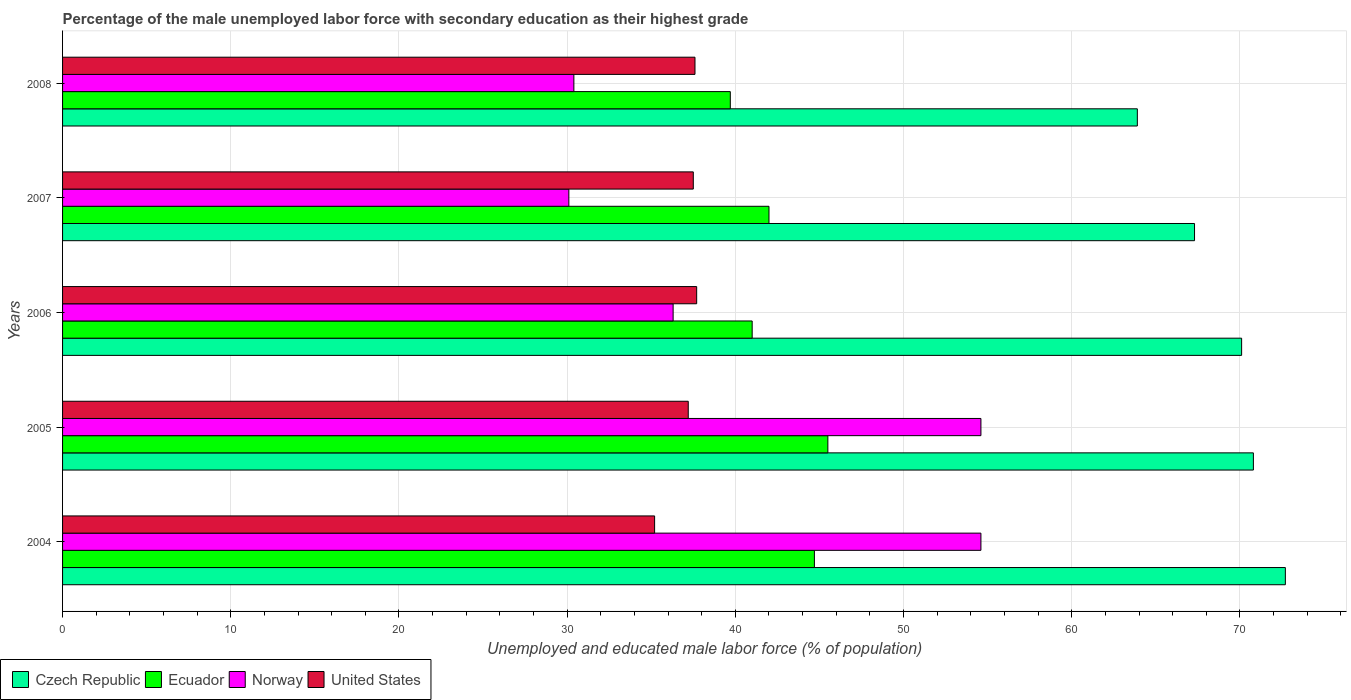How many groups of bars are there?
Give a very brief answer. 5. How many bars are there on the 3rd tick from the top?
Offer a very short reply. 4. How many bars are there on the 4th tick from the bottom?
Offer a very short reply. 4. What is the label of the 1st group of bars from the top?
Keep it short and to the point. 2008. What is the percentage of the unemployed male labor force with secondary education in Czech Republic in 2006?
Your answer should be very brief. 70.1. Across all years, what is the maximum percentage of the unemployed male labor force with secondary education in Ecuador?
Your response must be concise. 45.5. Across all years, what is the minimum percentage of the unemployed male labor force with secondary education in Ecuador?
Your response must be concise. 39.7. In which year was the percentage of the unemployed male labor force with secondary education in Czech Republic maximum?
Offer a very short reply. 2004. What is the total percentage of the unemployed male labor force with secondary education in United States in the graph?
Make the answer very short. 185.2. What is the difference between the percentage of the unemployed male labor force with secondary education in Norway in 2005 and that in 2008?
Offer a very short reply. 24.2. What is the difference between the percentage of the unemployed male labor force with secondary education in Czech Republic in 2004 and the percentage of the unemployed male labor force with secondary education in United States in 2006?
Make the answer very short. 35. What is the average percentage of the unemployed male labor force with secondary education in Norway per year?
Offer a very short reply. 41.2. In the year 2005, what is the difference between the percentage of the unemployed male labor force with secondary education in United States and percentage of the unemployed male labor force with secondary education in Ecuador?
Give a very brief answer. -8.3. In how many years, is the percentage of the unemployed male labor force with secondary education in Ecuador greater than 42 %?
Keep it short and to the point. 2. What is the ratio of the percentage of the unemployed male labor force with secondary education in Czech Republic in 2007 to that in 2008?
Provide a short and direct response. 1.05. Is the difference between the percentage of the unemployed male labor force with secondary education in United States in 2006 and 2008 greater than the difference between the percentage of the unemployed male labor force with secondary education in Ecuador in 2006 and 2008?
Offer a very short reply. No. What is the difference between the highest and the second highest percentage of the unemployed male labor force with secondary education in Norway?
Keep it short and to the point. 0. What is the difference between the highest and the lowest percentage of the unemployed male labor force with secondary education in Ecuador?
Your answer should be compact. 5.8. In how many years, is the percentage of the unemployed male labor force with secondary education in Czech Republic greater than the average percentage of the unemployed male labor force with secondary education in Czech Republic taken over all years?
Ensure brevity in your answer.  3. Is the sum of the percentage of the unemployed male labor force with secondary education in United States in 2007 and 2008 greater than the maximum percentage of the unemployed male labor force with secondary education in Norway across all years?
Your response must be concise. Yes. What does the 2nd bar from the top in 2006 represents?
Offer a terse response. Norway. What does the 2nd bar from the bottom in 2004 represents?
Give a very brief answer. Ecuador. Is it the case that in every year, the sum of the percentage of the unemployed male labor force with secondary education in Norway and percentage of the unemployed male labor force with secondary education in Czech Republic is greater than the percentage of the unemployed male labor force with secondary education in United States?
Keep it short and to the point. Yes. How many bars are there?
Provide a succinct answer. 20. Are all the bars in the graph horizontal?
Your answer should be very brief. Yes. Are the values on the major ticks of X-axis written in scientific E-notation?
Keep it short and to the point. No. Does the graph contain any zero values?
Your response must be concise. No. Does the graph contain grids?
Your answer should be compact. Yes. Where does the legend appear in the graph?
Provide a short and direct response. Bottom left. How many legend labels are there?
Ensure brevity in your answer.  4. How are the legend labels stacked?
Make the answer very short. Horizontal. What is the title of the graph?
Make the answer very short. Percentage of the male unemployed labor force with secondary education as their highest grade. Does "United Arab Emirates" appear as one of the legend labels in the graph?
Offer a terse response. No. What is the label or title of the X-axis?
Give a very brief answer. Unemployed and educated male labor force (% of population). What is the label or title of the Y-axis?
Provide a short and direct response. Years. What is the Unemployed and educated male labor force (% of population) in Czech Republic in 2004?
Provide a succinct answer. 72.7. What is the Unemployed and educated male labor force (% of population) of Ecuador in 2004?
Provide a short and direct response. 44.7. What is the Unemployed and educated male labor force (% of population) in Norway in 2004?
Keep it short and to the point. 54.6. What is the Unemployed and educated male labor force (% of population) in United States in 2004?
Keep it short and to the point. 35.2. What is the Unemployed and educated male labor force (% of population) of Czech Republic in 2005?
Keep it short and to the point. 70.8. What is the Unemployed and educated male labor force (% of population) of Ecuador in 2005?
Give a very brief answer. 45.5. What is the Unemployed and educated male labor force (% of population) of Norway in 2005?
Offer a very short reply. 54.6. What is the Unemployed and educated male labor force (% of population) of United States in 2005?
Keep it short and to the point. 37.2. What is the Unemployed and educated male labor force (% of population) in Czech Republic in 2006?
Make the answer very short. 70.1. What is the Unemployed and educated male labor force (% of population) of Norway in 2006?
Your response must be concise. 36.3. What is the Unemployed and educated male labor force (% of population) of United States in 2006?
Provide a succinct answer. 37.7. What is the Unemployed and educated male labor force (% of population) of Czech Republic in 2007?
Your answer should be compact. 67.3. What is the Unemployed and educated male labor force (% of population) in Norway in 2007?
Your answer should be compact. 30.1. What is the Unemployed and educated male labor force (% of population) in United States in 2007?
Keep it short and to the point. 37.5. What is the Unemployed and educated male labor force (% of population) of Czech Republic in 2008?
Your answer should be very brief. 63.9. What is the Unemployed and educated male labor force (% of population) in Ecuador in 2008?
Make the answer very short. 39.7. What is the Unemployed and educated male labor force (% of population) in Norway in 2008?
Provide a short and direct response. 30.4. What is the Unemployed and educated male labor force (% of population) in United States in 2008?
Provide a short and direct response. 37.6. Across all years, what is the maximum Unemployed and educated male labor force (% of population) in Czech Republic?
Provide a short and direct response. 72.7. Across all years, what is the maximum Unemployed and educated male labor force (% of population) of Ecuador?
Make the answer very short. 45.5. Across all years, what is the maximum Unemployed and educated male labor force (% of population) of Norway?
Make the answer very short. 54.6. Across all years, what is the maximum Unemployed and educated male labor force (% of population) in United States?
Offer a very short reply. 37.7. Across all years, what is the minimum Unemployed and educated male labor force (% of population) in Czech Republic?
Provide a succinct answer. 63.9. Across all years, what is the minimum Unemployed and educated male labor force (% of population) in Ecuador?
Offer a terse response. 39.7. Across all years, what is the minimum Unemployed and educated male labor force (% of population) of Norway?
Your response must be concise. 30.1. Across all years, what is the minimum Unemployed and educated male labor force (% of population) in United States?
Your answer should be compact. 35.2. What is the total Unemployed and educated male labor force (% of population) of Czech Republic in the graph?
Offer a very short reply. 344.8. What is the total Unemployed and educated male labor force (% of population) of Ecuador in the graph?
Your response must be concise. 212.9. What is the total Unemployed and educated male labor force (% of population) in Norway in the graph?
Give a very brief answer. 206. What is the total Unemployed and educated male labor force (% of population) of United States in the graph?
Give a very brief answer. 185.2. What is the difference between the Unemployed and educated male labor force (% of population) in Czech Republic in 2004 and that in 2005?
Your response must be concise. 1.9. What is the difference between the Unemployed and educated male labor force (% of population) in Ecuador in 2004 and that in 2005?
Offer a terse response. -0.8. What is the difference between the Unemployed and educated male labor force (% of population) in United States in 2004 and that in 2005?
Your answer should be compact. -2. What is the difference between the Unemployed and educated male labor force (% of population) of Czech Republic in 2004 and that in 2006?
Offer a terse response. 2.6. What is the difference between the Unemployed and educated male labor force (% of population) of Ecuador in 2004 and that in 2006?
Provide a succinct answer. 3.7. What is the difference between the Unemployed and educated male labor force (% of population) in Norway in 2004 and that in 2006?
Make the answer very short. 18.3. What is the difference between the Unemployed and educated male labor force (% of population) in Czech Republic in 2004 and that in 2007?
Offer a very short reply. 5.4. What is the difference between the Unemployed and educated male labor force (% of population) in Ecuador in 2004 and that in 2007?
Your response must be concise. 2.7. What is the difference between the Unemployed and educated male labor force (% of population) in Ecuador in 2004 and that in 2008?
Your answer should be compact. 5. What is the difference between the Unemployed and educated male labor force (% of population) in Norway in 2004 and that in 2008?
Provide a short and direct response. 24.2. What is the difference between the Unemployed and educated male labor force (% of population) in United States in 2004 and that in 2008?
Ensure brevity in your answer.  -2.4. What is the difference between the Unemployed and educated male labor force (% of population) in Czech Republic in 2005 and that in 2006?
Your answer should be very brief. 0.7. What is the difference between the Unemployed and educated male labor force (% of population) in Ecuador in 2005 and that in 2006?
Offer a terse response. 4.5. What is the difference between the Unemployed and educated male labor force (% of population) in Norway in 2005 and that in 2006?
Provide a succinct answer. 18.3. What is the difference between the Unemployed and educated male labor force (% of population) in Czech Republic in 2005 and that in 2007?
Your response must be concise. 3.5. What is the difference between the Unemployed and educated male labor force (% of population) of Norway in 2005 and that in 2007?
Your answer should be compact. 24.5. What is the difference between the Unemployed and educated male labor force (% of population) in United States in 2005 and that in 2007?
Offer a very short reply. -0.3. What is the difference between the Unemployed and educated male labor force (% of population) in Norway in 2005 and that in 2008?
Provide a short and direct response. 24.2. What is the difference between the Unemployed and educated male labor force (% of population) in United States in 2005 and that in 2008?
Offer a terse response. -0.4. What is the difference between the Unemployed and educated male labor force (% of population) in Ecuador in 2006 and that in 2007?
Offer a terse response. -1. What is the difference between the Unemployed and educated male labor force (% of population) in Ecuador in 2006 and that in 2008?
Your answer should be compact. 1.3. What is the difference between the Unemployed and educated male labor force (% of population) in United States in 2006 and that in 2008?
Keep it short and to the point. 0.1. What is the difference between the Unemployed and educated male labor force (% of population) in Czech Republic in 2007 and that in 2008?
Offer a very short reply. 3.4. What is the difference between the Unemployed and educated male labor force (% of population) in Norway in 2007 and that in 2008?
Provide a short and direct response. -0.3. What is the difference between the Unemployed and educated male labor force (% of population) in United States in 2007 and that in 2008?
Provide a short and direct response. -0.1. What is the difference between the Unemployed and educated male labor force (% of population) of Czech Republic in 2004 and the Unemployed and educated male labor force (% of population) of Ecuador in 2005?
Provide a short and direct response. 27.2. What is the difference between the Unemployed and educated male labor force (% of population) in Czech Republic in 2004 and the Unemployed and educated male labor force (% of population) in Norway in 2005?
Your answer should be very brief. 18.1. What is the difference between the Unemployed and educated male labor force (% of population) of Czech Republic in 2004 and the Unemployed and educated male labor force (% of population) of United States in 2005?
Offer a very short reply. 35.5. What is the difference between the Unemployed and educated male labor force (% of population) of Ecuador in 2004 and the Unemployed and educated male labor force (% of population) of Norway in 2005?
Offer a terse response. -9.9. What is the difference between the Unemployed and educated male labor force (% of population) of Czech Republic in 2004 and the Unemployed and educated male labor force (% of population) of Ecuador in 2006?
Make the answer very short. 31.7. What is the difference between the Unemployed and educated male labor force (% of population) of Czech Republic in 2004 and the Unemployed and educated male labor force (% of population) of Norway in 2006?
Ensure brevity in your answer.  36.4. What is the difference between the Unemployed and educated male labor force (% of population) in Ecuador in 2004 and the Unemployed and educated male labor force (% of population) in Norway in 2006?
Provide a succinct answer. 8.4. What is the difference between the Unemployed and educated male labor force (% of population) of Ecuador in 2004 and the Unemployed and educated male labor force (% of population) of United States in 2006?
Make the answer very short. 7. What is the difference between the Unemployed and educated male labor force (% of population) in Norway in 2004 and the Unemployed and educated male labor force (% of population) in United States in 2006?
Ensure brevity in your answer.  16.9. What is the difference between the Unemployed and educated male labor force (% of population) of Czech Republic in 2004 and the Unemployed and educated male labor force (% of population) of Ecuador in 2007?
Your answer should be very brief. 30.7. What is the difference between the Unemployed and educated male labor force (% of population) in Czech Republic in 2004 and the Unemployed and educated male labor force (% of population) in Norway in 2007?
Your answer should be very brief. 42.6. What is the difference between the Unemployed and educated male labor force (% of population) in Czech Republic in 2004 and the Unemployed and educated male labor force (% of population) in United States in 2007?
Offer a terse response. 35.2. What is the difference between the Unemployed and educated male labor force (% of population) of Czech Republic in 2004 and the Unemployed and educated male labor force (% of population) of Norway in 2008?
Provide a short and direct response. 42.3. What is the difference between the Unemployed and educated male labor force (% of population) of Czech Republic in 2004 and the Unemployed and educated male labor force (% of population) of United States in 2008?
Make the answer very short. 35.1. What is the difference between the Unemployed and educated male labor force (% of population) of Ecuador in 2004 and the Unemployed and educated male labor force (% of population) of Norway in 2008?
Give a very brief answer. 14.3. What is the difference between the Unemployed and educated male labor force (% of population) of Ecuador in 2004 and the Unemployed and educated male labor force (% of population) of United States in 2008?
Offer a very short reply. 7.1. What is the difference between the Unemployed and educated male labor force (% of population) of Norway in 2004 and the Unemployed and educated male labor force (% of population) of United States in 2008?
Make the answer very short. 17. What is the difference between the Unemployed and educated male labor force (% of population) of Czech Republic in 2005 and the Unemployed and educated male labor force (% of population) of Ecuador in 2006?
Offer a terse response. 29.8. What is the difference between the Unemployed and educated male labor force (% of population) of Czech Republic in 2005 and the Unemployed and educated male labor force (% of population) of Norway in 2006?
Keep it short and to the point. 34.5. What is the difference between the Unemployed and educated male labor force (% of population) in Czech Republic in 2005 and the Unemployed and educated male labor force (% of population) in United States in 2006?
Make the answer very short. 33.1. What is the difference between the Unemployed and educated male labor force (% of population) of Ecuador in 2005 and the Unemployed and educated male labor force (% of population) of Norway in 2006?
Give a very brief answer. 9.2. What is the difference between the Unemployed and educated male labor force (% of population) of Ecuador in 2005 and the Unemployed and educated male labor force (% of population) of United States in 2006?
Make the answer very short. 7.8. What is the difference between the Unemployed and educated male labor force (% of population) in Czech Republic in 2005 and the Unemployed and educated male labor force (% of population) in Ecuador in 2007?
Your answer should be very brief. 28.8. What is the difference between the Unemployed and educated male labor force (% of population) of Czech Republic in 2005 and the Unemployed and educated male labor force (% of population) of Norway in 2007?
Offer a terse response. 40.7. What is the difference between the Unemployed and educated male labor force (% of population) of Czech Republic in 2005 and the Unemployed and educated male labor force (% of population) of United States in 2007?
Provide a succinct answer. 33.3. What is the difference between the Unemployed and educated male labor force (% of population) of Czech Republic in 2005 and the Unemployed and educated male labor force (% of population) of Ecuador in 2008?
Offer a very short reply. 31.1. What is the difference between the Unemployed and educated male labor force (% of population) of Czech Republic in 2005 and the Unemployed and educated male labor force (% of population) of Norway in 2008?
Make the answer very short. 40.4. What is the difference between the Unemployed and educated male labor force (% of population) of Czech Republic in 2005 and the Unemployed and educated male labor force (% of population) of United States in 2008?
Ensure brevity in your answer.  33.2. What is the difference between the Unemployed and educated male labor force (% of population) of Ecuador in 2005 and the Unemployed and educated male labor force (% of population) of Norway in 2008?
Your response must be concise. 15.1. What is the difference between the Unemployed and educated male labor force (% of population) in Czech Republic in 2006 and the Unemployed and educated male labor force (% of population) in Ecuador in 2007?
Your answer should be very brief. 28.1. What is the difference between the Unemployed and educated male labor force (% of population) of Czech Republic in 2006 and the Unemployed and educated male labor force (% of population) of Norway in 2007?
Your response must be concise. 40. What is the difference between the Unemployed and educated male labor force (% of population) of Czech Republic in 2006 and the Unemployed and educated male labor force (% of population) of United States in 2007?
Your response must be concise. 32.6. What is the difference between the Unemployed and educated male labor force (% of population) in Norway in 2006 and the Unemployed and educated male labor force (% of population) in United States in 2007?
Make the answer very short. -1.2. What is the difference between the Unemployed and educated male labor force (% of population) in Czech Republic in 2006 and the Unemployed and educated male labor force (% of population) in Ecuador in 2008?
Offer a terse response. 30.4. What is the difference between the Unemployed and educated male labor force (% of population) of Czech Republic in 2006 and the Unemployed and educated male labor force (% of population) of Norway in 2008?
Make the answer very short. 39.7. What is the difference between the Unemployed and educated male labor force (% of population) of Czech Republic in 2006 and the Unemployed and educated male labor force (% of population) of United States in 2008?
Provide a succinct answer. 32.5. What is the difference between the Unemployed and educated male labor force (% of population) of Ecuador in 2006 and the Unemployed and educated male labor force (% of population) of Norway in 2008?
Ensure brevity in your answer.  10.6. What is the difference between the Unemployed and educated male labor force (% of population) of Czech Republic in 2007 and the Unemployed and educated male labor force (% of population) of Ecuador in 2008?
Offer a very short reply. 27.6. What is the difference between the Unemployed and educated male labor force (% of population) in Czech Republic in 2007 and the Unemployed and educated male labor force (% of population) in Norway in 2008?
Your answer should be very brief. 36.9. What is the difference between the Unemployed and educated male labor force (% of population) of Czech Republic in 2007 and the Unemployed and educated male labor force (% of population) of United States in 2008?
Give a very brief answer. 29.7. What is the difference between the Unemployed and educated male labor force (% of population) of Ecuador in 2007 and the Unemployed and educated male labor force (% of population) of Norway in 2008?
Your answer should be compact. 11.6. What is the average Unemployed and educated male labor force (% of population) of Czech Republic per year?
Offer a very short reply. 68.96. What is the average Unemployed and educated male labor force (% of population) of Ecuador per year?
Ensure brevity in your answer.  42.58. What is the average Unemployed and educated male labor force (% of population) of Norway per year?
Provide a succinct answer. 41.2. What is the average Unemployed and educated male labor force (% of population) in United States per year?
Give a very brief answer. 37.04. In the year 2004, what is the difference between the Unemployed and educated male labor force (% of population) in Czech Republic and Unemployed and educated male labor force (% of population) in United States?
Provide a short and direct response. 37.5. In the year 2004, what is the difference between the Unemployed and educated male labor force (% of population) in Ecuador and Unemployed and educated male labor force (% of population) in Norway?
Offer a very short reply. -9.9. In the year 2005, what is the difference between the Unemployed and educated male labor force (% of population) of Czech Republic and Unemployed and educated male labor force (% of population) of Ecuador?
Ensure brevity in your answer.  25.3. In the year 2005, what is the difference between the Unemployed and educated male labor force (% of population) in Czech Republic and Unemployed and educated male labor force (% of population) in Norway?
Your answer should be compact. 16.2. In the year 2005, what is the difference between the Unemployed and educated male labor force (% of population) of Czech Republic and Unemployed and educated male labor force (% of population) of United States?
Make the answer very short. 33.6. In the year 2005, what is the difference between the Unemployed and educated male labor force (% of population) in Ecuador and Unemployed and educated male labor force (% of population) in Norway?
Ensure brevity in your answer.  -9.1. In the year 2005, what is the difference between the Unemployed and educated male labor force (% of population) of Norway and Unemployed and educated male labor force (% of population) of United States?
Offer a very short reply. 17.4. In the year 2006, what is the difference between the Unemployed and educated male labor force (% of population) of Czech Republic and Unemployed and educated male labor force (% of population) of Ecuador?
Your response must be concise. 29.1. In the year 2006, what is the difference between the Unemployed and educated male labor force (% of population) of Czech Republic and Unemployed and educated male labor force (% of population) of Norway?
Your response must be concise. 33.8. In the year 2006, what is the difference between the Unemployed and educated male labor force (% of population) in Czech Republic and Unemployed and educated male labor force (% of population) in United States?
Give a very brief answer. 32.4. In the year 2006, what is the difference between the Unemployed and educated male labor force (% of population) of Ecuador and Unemployed and educated male labor force (% of population) of United States?
Offer a terse response. 3.3. In the year 2006, what is the difference between the Unemployed and educated male labor force (% of population) of Norway and Unemployed and educated male labor force (% of population) of United States?
Make the answer very short. -1.4. In the year 2007, what is the difference between the Unemployed and educated male labor force (% of population) in Czech Republic and Unemployed and educated male labor force (% of population) in Ecuador?
Give a very brief answer. 25.3. In the year 2007, what is the difference between the Unemployed and educated male labor force (% of population) of Czech Republic and Unemployed and educated male labor force (% of population) of Norway?
Your response must be concise. 37.2. In the year 2007, what is the difference between the Unemployed and educated male labor force (% of population) in Czech Republic and Unemployed and educated male labor force (% of population) in United States?
Make the answer very short. 29.8. In the year 2007, what is the difference between the Unemployed and educated male labor force (% of population) of Norway and Unemployed and educated male labor force (% of population) of United States?
Make the answer very short. -7.4. In the year 2008, what is the difference between the Unemployed and educated male labor force (% of population) in Czech Republic and Unemployed and educated male labor force (% of population) in Ecuador?
Your answer should be very brief. 24.2. In the year 2008, what is the difference between the Unemployed and educated male labor force (% of population) in Czech Republic and Unemployed and educated male labor force (% of population) in Norway?
Provide a succinct answer. 33.5. In the year 2008, what is the difference between the Unemployed and educated male labor force (% of population) in Czech Republic and Unemployed and educated male labor force (% of population) in United States?
Ensure brevity in your answer.  26.3. In the year 2008, what is the difference between the Unemployed and educated male labor force (% of population) of Ecuador and Unemployed and educated male labor force (% of population) of United States?
Offer a terse response. 2.1. What is the ratio of the Unemployed and educated male labor force (% of population) of Czech Republic in 2004 to that in 2005?
Ensure brevity in your answer.  1.03. What is the ratio of the Unemployed and educated male labor force (% of population) in Ecuador in 2004 to that in 2005?
Offer a very short reply. 0.98. What is the ratio of the Unemployed and educated male labor force (% of population) in Norway in 2004 to that in 2005?
Offer a terse response. 1. What is the ratio of the Unemployed and educated male labor force (% of population) in United States in 2004 to that in 2005?
Keep it short and to the point. 0.95. What is the ratio of the Unemployed and educated male labor force (% of population) of Czech Republic in 2004 to that in 2006?
Provide a succinct answer. 1.04. What is the ratio of the Unemployed and educated male labor force (% of population) in Ecuador in 2004 to that in 2006?
Provide a succinct answer. 1.09. What is the ratio of the Unemployed and educated male labor force (% of population) of Norway in 2004 to that in 2006?
Provide a succinct answer. 1.5. What is the ratio of the Unemployed and educated male labor force (% of population) of United States in 2004 to that in 2006?
Give a very brief answer. 0.93. What is the ratio of the Unemployed and educated male labor force (% of population) in Czech Republic in 2004 to that in 2007?
Provide a short and direct response. 1.08. What is the ratio of the Unemployed and educated male labor force (% of population) in Ecuador in 2004 to that in 2007?
Your answer should be compact. 1.06. What is the ratio of the Unemployed and educated male labor force (% of population) of Norway in 2004 to that in 2007?
Your answer should be compact. 1.81. What is the ratio of the Unemployed and educated male labor force (% of population) in United States in 2004 to that in 2007?
Your answer should be very brief. 0.94. What is the ratio of the Unemployed and educated male labor force (% of population) of Czech Republic in 2004 to that in 2008?
Provide a succinct answer. 1.14. What is the ratio of the Unemployed and educated male labor force (% of population) of Ecuador in 2004 to that in 2008?
Your answer should be very brief. 1.13. What is the ratio of the Unemployed and educated male labor force (% of population) of Norway in 2004 to that in 2008?
Provide a succinct answer. 1.8. What is the ratio of the Unemployed and educated male labor force (% of population) in United States in 2004 to that in 2008?
Ensure brevity in your answer.  0.94. What is the ratio of the Unemployed and educated male labor force (% of population) in Czech Republic in 2005 to that in 2006?
Your response must be concise. 1.01. What is the ratio of the Unemployed and educated male labor force (% of population) of Ecuador in 2005 to that in 2006?
Your answer should be compact. 1.11. What is the ratio of the Unemployed and educated male labor force (% of population) of Norway in 2005 to that in 2006?
Your answer should be very brief. 1.5. What is the ratio of the Unemployed and educated male labor force (% of population) in United States in 2005 to that in 2006?
Ensure brevity in your answer.  0.99. What is the ratio of the Unemployed and educated male labor force (% of population) of Czech Republic in 2005 to that in 2007?
Provide a succinct answer. 1.05. What is the ratio of the Unemployed and educated male labor force (% of population) of Ecuador in 2005 to that in 2007?
Offer a terse response. 1.08. What is the ratio of the Unemployed and educated male labor force (% of population) of Norway in 2005 to that in 2007?
Your answer should be very brief. 1.81. What is the ratio of the Unemployed and educated male labor force (% of population) of United States in 2005 to that in 2007?
Offer a very short reply. 0.99. What is the ratio of the Unemployed and educated male labor force (% of population) in Czech Republic in 2005 to that in 2008?
Your response must be concise. 1.11. What is the ratio of the Unemployed and educated male labor force (% of population) of Ecuador in 2005 to that in 2008?
Make the answer very short. 1.15. What is the ratio of the Unemployed and educated male labor force (% of population) in Norway in 2005 to that in 2008?
Your answer should be compact. 1.8. What is the ratio of the Unemployed and educated male labor force (% of population) in Czech Republic in 2006 to that in 2007?
Your answer should be very brief. 1.04. What is the ratio of the Unemployed and educated male labor force (% of population) of Ecuador in 2006 to that in 2007?
Your answer should be compact. 0.98. What is the ratio of the Unemployed and educated male labor force (% of population) in Norway in 2006 to that in 2007?
Give a very brief answer. 1.21. What is the ratio of the Unemployed and educated male labor force (% of population) in Czech Republic in 2006 to that in 2008?
Make the answer very short. 1.1. What is the ratio of the Unemployed and educated male labor force (% of population) in Ecuador in 2006 to that in 2008?
Ensure brevity in your answer.  1.03. What is the ratio of the Unemployed and educated male labor force (% of population) in Norway in 2006 to that in 2008?
Give a very brief answer. 1.19. What is the ratio of the Unemployed and educated male labor force (% of population) in United States in 2006 to that in 2008?
Your answer should be very brief. 1. What is the ratio of the Unemployed and educated male labor force (% of population) of Czech Republic in 2007 to that in 2008?
Give a very brief answer. 1.05. What is the ratio of the Unemployed and educated male labor force (% of population) in Ecuador in 2007 to that in 2008?
Offer a very short reply. 1.06. What is the ratio of the Unemployed and educated male labor force (% of population) of United States in 2007 to that in 2008?
Provide a succinct answer. 1. What is the difference between the highest and the second highest Unemployed and educated male labor force (% of population) of Ecuador?
Offer a terse response. 0.8. What is the difference between the highest and the second highest Unemployed and educated male labor force (% of population) of Norway?
Your answer should be compact. 0. What is the difference between the highest and the lowest Unemployed and educated male labor force (% of population) of Czech Republic?
Offer a terse response. 8.8. 